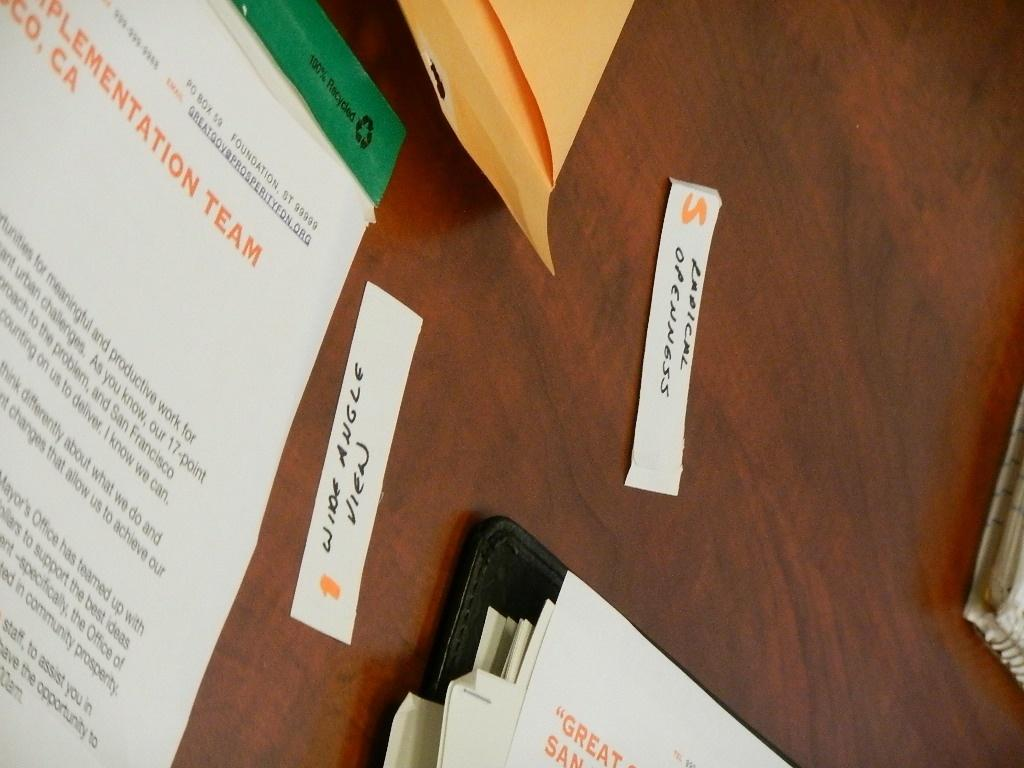<image>
Provide a brief description of the given image. Government foundation organization documents laying on a table. 